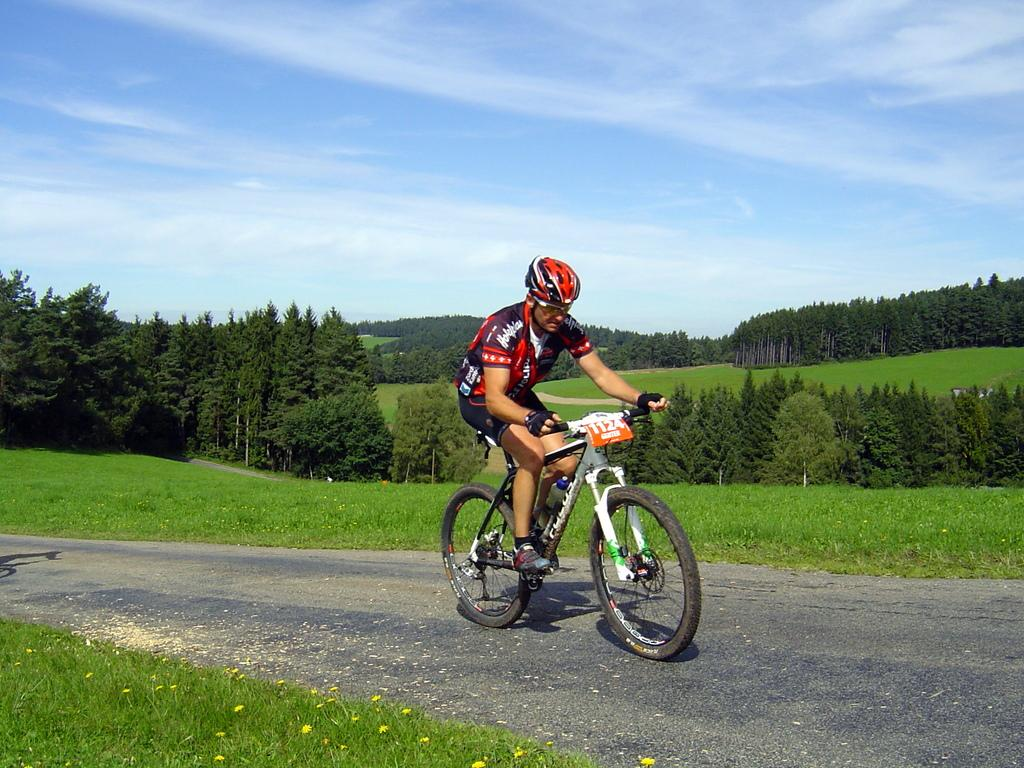What is the man in the image doing? The man is riding a bicycle on the road. What type of terrain can be seen in the image? There is grass visible in the image. What can be seen in the background of the image? There are trees and the sky visible in the background of the image. What type of box does the man receive as a reward for riding his bicycle in the image? There is no box or reward mentioned or depicted in the image. 